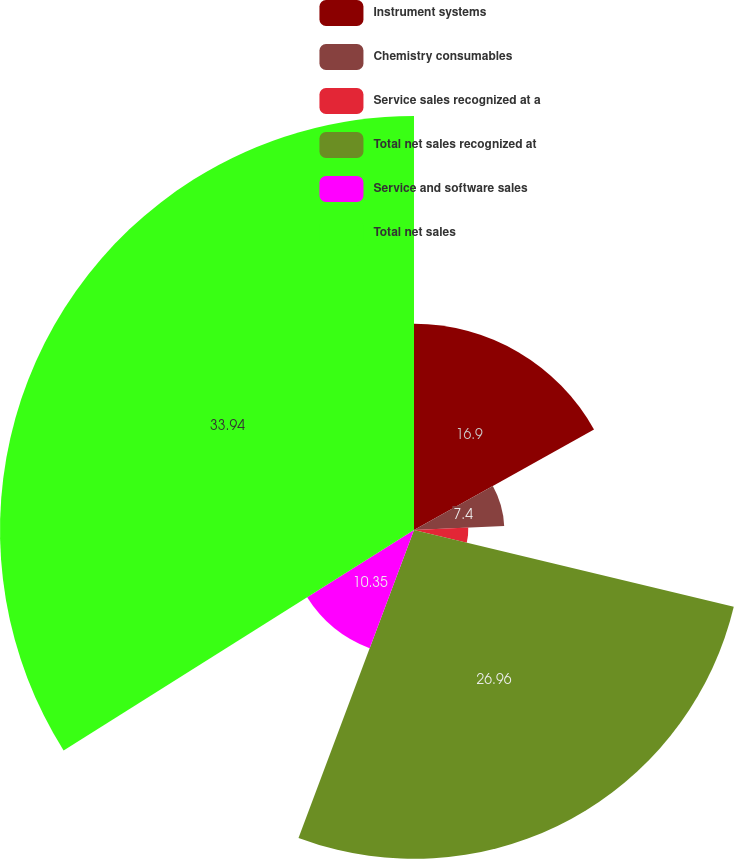Convert chart to OTSL. <chart><loc_0><loc_0><loc_500><loc_500><pie_chart><fcel>Instrument systems<fcel>Chemistry consumables<fcel>Service sales recognized at a<fcel>Total net sales recognized at<fcel>Service and software sales<fcel>Total net sales<nl><fcel>16.9%<fcel>7.4%<fcel>4.45%<fcel>26.96%<fcel>10.35%<fcel>33.94%<nl></chart> 